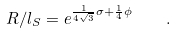<formula> <loc_0><loc_0><loc_500><loc_500>R / l _ { S } = e ^ { \frac { 1 } { 4 \sqrt { 3 } } \sigma + \frac { 1 } { 4 } \phi } \quad .</formula> 